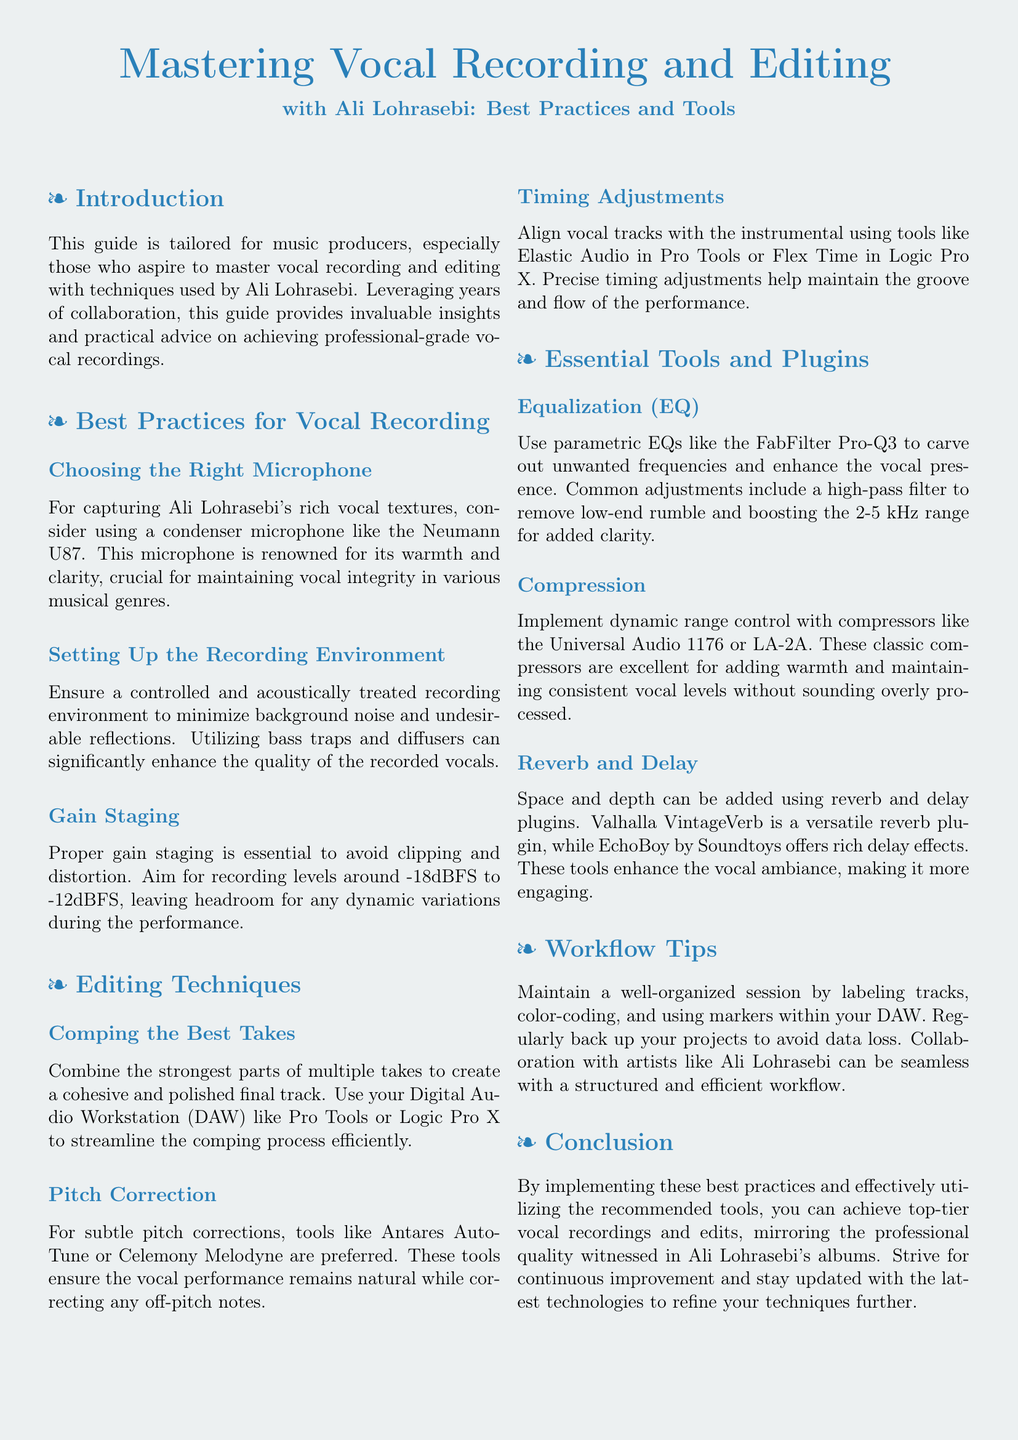What is the recommended microphone for vocal recording? The document mentions that for capturing Ali Lohrasebi's rich vocal textures, a condenser microphone like the Neumann U87 is recommended.
Answer: Neumann U87 What recording level is suggested for gain staging? According to the guide, the suggested recording levels for gain staging are around -18dBFS to -12dBFS.
Answer: -18dBFS to -12dBFS What is the purpose of using EQ in vocal recording? The guide explains that parametric EQs are used to carve out unwanted frequencies and enhance vocal presence.
Answer: Carve out unwanted frequencies and enhance vocal presence Which pitch correction tool is preferred for subtle corrections? The document states that Antares Auto-Tune or Celemony Melodyne are preferred for subtle pitch corrections.
Answer: Antares Auto-Tune or Celemony Melodyne What type of compressor is recommended to maintain consistent vocal levels? It is mentioned that classic compressors like the Universal Audio 1176 or LA-2A are excellent for maintaining consistent vocal levels.
Answer: Universal Audio 1176 or LA-2A What is one of the workflow tips provided in the guide? The guide advises maintaining a well-organized session by labeling tracks, color-coding, and using markers within the DAW.
Answer: Labeling tracks, color-coding, using markers What is the key focus of this user guide? The primary focus of this user guide is to master vocal recording and editing techniques used by Ali Lohrasebi.
Answer: Mastering vocal recording and editing techniques What type of environment is recommended for recording? The guide suggests ensuring a controlled and acoustically treated recording environment to minimize background noise.
Answer: Controlled and acoustically treated Which reverb plugin is mentioned as versatile? The document lists Valhalla VintageVerb as a versatile reverb plugin.
Answer: Valhalla VintageVerb 